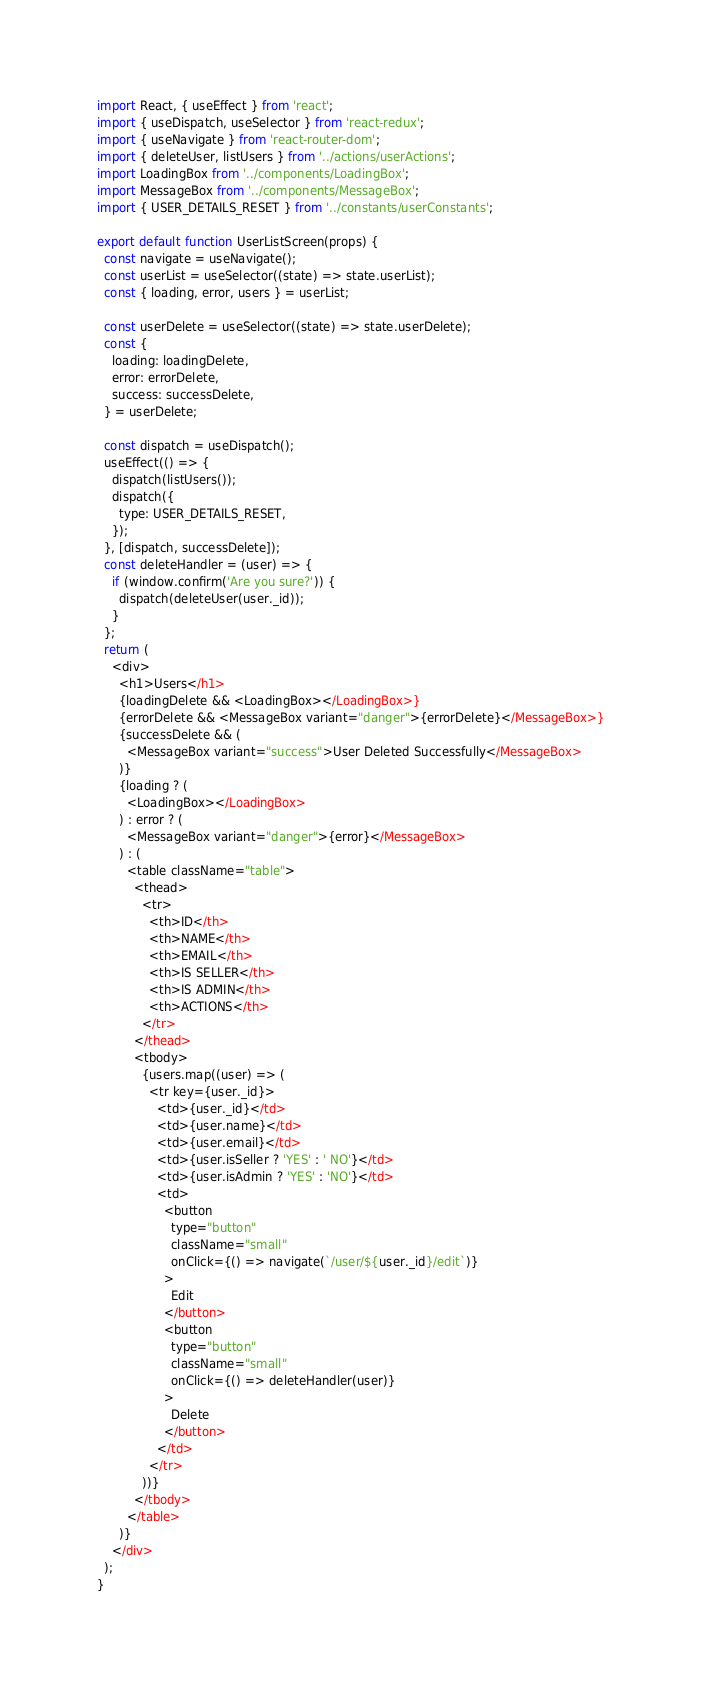Convert code to text. <code><loc_0><loc_0><loc_500><loc_500><_JavaScript_>import React, { useEffect } from 'react';
import { useDispatch, useSelector } from 'react-redux';
import { useNavigate } from 'react-router-dom';
import { deleteUser, listUsers } from '../actions/userActions';
import LoadingBox from '../components/LoadingBox';
import MessageBox from '../components/MessageBox';
import { USER_DETAILS_RESET } from '../constants/userConstants';

export default function UserListScreen(props) {
  const navigate = useNavigate();
  const userList = useSelector((state) => state.userList);
  const { loading, error, users } = userList;

  const userDelete = useSelector((state) => state.userDelete);
  const {
    loading: loadingDelete,
    error: errorDelete,
    success: successDelete,
  } = userDelete;

  const dispatch = useDispatch();
  useEffect(() => {
    dispatch(listUsers());
    dispatch({
      type: USER_DETAILS_RESET,
    });
  }, [dispatch, successDelete]);
  const deleteHandler = (user) => {
    if (window.confirm('Are you sure?')) {
      dispatch(deleteUser(user._id));
    }
  };
  return (
    <div>
      <h1>Users</h1>
      {loadingDelete && <LoadingBox></LoadingBox>}
      {errorDelete && <MessageBox variant="danger">{errorDelete}</MessageBox>}
      {successDelete && (
        <MessageBox variant="success">User Deleted Successfully</MessageBox>
      )}
      {loading ? (
        <LoadingBox></LoadingBox>
      ) : error ? (
        <MessageBox variant="danger">{error}</MessageBox>
      ) : (
        <table className="table">
          <thead>
            <tr>
              <th>ID</th>
              <th>NAME</th>
              <th>EMAIL</th>
              <th>IS SELLER</th>
              <th>IS ADMIN</th>
              <th>ACTIONS</th>
            </tr>
          </thead>
          <tbody>
            {users.map((user) => (
              <tr key={user._id}>
                <td>{user._id}</td>
                <td>{user.name}</td>
                <td>{user.email}</td>
                <td>{user.isSeller ? 'YES' : ' NO'}</td>
                <td>{user.isAdmin ? 'YES' : 'NO'}</td>
                <td>
                  <button
                    type="button"
                    className="small"
                    onClick={() => navigate(`/user/${user._id}/edit`)}
                  >
                    Edit
                  </button>
                  <button
                    type="button"
                    className="small"
                    onClick={() => deleteHandler(user)}
                  >
                    Delete
                  </button>
                </td>
              </tr>
            ))}
          </tbody>
        </table>
      )}
    </div>
  );
}
</code> 